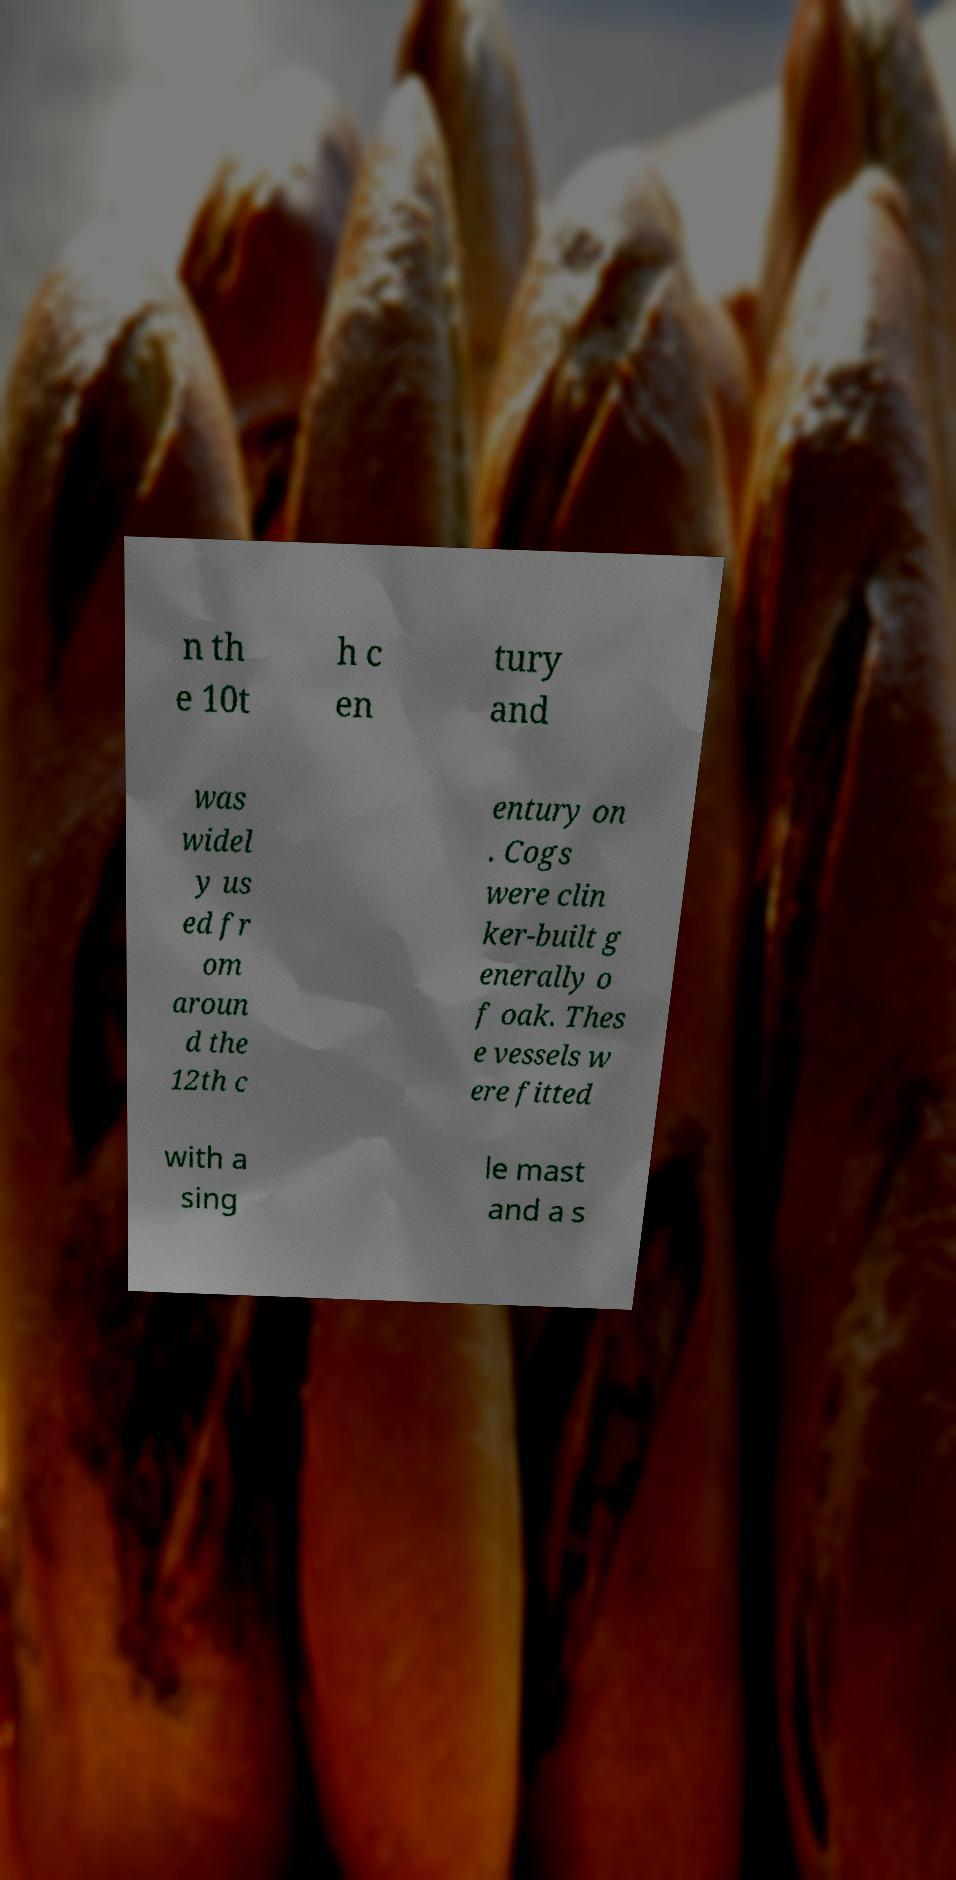Can you accurately transcribe the text from the provided image for me? n th e 10t h c en tury and was widel y us ed fr om aroun d the 12th c entury on . Cogs were clin ker-built g enerally o f oak. Thes e vessels w ere fitted with a sing le mast and a s 